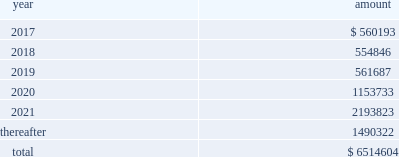New term loan a facility , with the remaining unpaid principal amount of loans under the new term loan a facility due and payable in full at maturity on june 6 , 2021 .
Principal amounts outstanding under the new revolving loan facility are due and payable in full at maturity on june 6 , 2021 , subject to earlier repayment pursuant to the springing maturity date described above .
In addition to paying interest on outstanding principal under the borrowings , we are obligated to pay a quarterly commitment fee at a rate determined by reference to a total leverage ratio , with a maximum commitment fee of 40% ( 40 % ) of the applicable margin for eurocurrency loans .
In july 2016 , breakaway four , ltd. , as borrower , and nclc , as guarantor , entered into a supplemental agreement , which amended the breakaway four loan to , among other things , increase the aggregate principal amount of commitments under the multi-draw term loan credit facility from 20ac590.5 million to 20ac729.9 million .
In june 2016 , we took delivery of seven seas explorer .
To finance the payment due upon delivery , we had export credit financing in place for 80% ( 80 % ) of the contract price .
The associated $ 373.6 million term loan bears interest at 3.43% ( 3.43 % ) with a maturity date of june 30 , 2028 .
Principal and interest payments shall be paid semiannually .
In december 2016 , nclc issued $ 700.0 million aggregate principal amount of 4.750% ( 4.750 % ) senior unsecured notes due december 2021 ( the 201cnotes 201d ) in a private offering ( the 201coffering 201d ) at par .
Nclc used the net proceeds from the offering , after deducting the initial purchasers 2019 discount and estimated fees and expenses , together with cash on hand , to purchase its outstanding 5.25% ( 5.25 % ) senior notes due 2019 having an aggregate outstanding principal amount of $ 680 million .
The redemption of the 5.25% ( 5.25 % ) senior notes due 2019 was completed in january 2017 .
Nclc will pay interest on the notes at 4.750% ( 4.750 % ) per annum , semiannually on june 15 and december 15 of each year , commencing on june 15 , 2017 , to holders of record at the close of business on the immediately preceding june 1 and december 1 , respectively .
Nclc may redeem the notes , in whole or part , at any time prior to december 15 , 2018 , at a price equal to 100% ( 100 % ) of the principal amount of the notes redeemed plus accrued and unpaid interest to , but not including , the redemption date and a 201cmake-whole premium . 201d nclc may redeem the notes , in whole or in part , on or after december 15 , 2018 , at the redemption prices set forth in the indenture governing the notes .
At any time ( which may be more than once ) on or prior to december 15 , 2018 , nclc may choose to redeem up to 40% ( 40 % ) of the aggregate principal amount of the notes at a redemption price equal to 104.750% ( 104.750 % ) of the face amount thereof with an amount equal to the net proceeds of one or more equity offerings , so long as at least 60% ( 60 % ) of the aggregate principal amount of the notes issued remains outstanding following such redemption .
The indenture governing the notes contains covenants that limit nclc 2019s ability ( and its restricted subsidiaries 2019 ability ) to , among other things : ( i ) incur or guarantee additional indebtedness or issue certain preferred shares ; ( ii ) pay dividends and make certain other restricted payments ; ( iii ) create restrictions on the payment of dividends or other distributions to nclc from its restricted subsidiaries ; ( iv ) create liens on certain assets to secure debt ; ( v ) make certain investments ; ( vi ) engage in transactions with affiliates ; ( vii ) engage in sales of assets and subsidiary stock ; and ( viii ) transfer all or substantially all of its assets or enter into merger or consolidation transactions .
The indenture governing the notes also provides for events of default , which , if any of them occurs , would permit or require the principal , premium ( if any ) , interest and other monetary obligations on all of the then-outstanding notes to become due and payable immediately .
Interest expense , net for the year ended december 31 , 2016 was $ 276.9 million which included $ 34.7 million of amortization of deferred financing fees and a $ 27.7 million loss on extinguishment of debt .
Interest expense , net for the year ended december 31 , 2015 was $ 221.9 million which included $ 36.7 million of amortization of deferred financing fees and a $ 12.7 million loss on extinguishment of debt .
Interest expense , net for the year ended december 31 , 2014 was $ 151.8 million which included $ 32.3 million of amortization of deferred financing fees and $ 15.4 million of expenses related to financing transactions in connection with the acquisition of prestige .
Certain of our debt agreements contain covenants that , among other things , require us to maintain a minimum level of liquidity , as well as limit our net funded debt-to-capital ratio , maintain certain other ratios and restrict our ability to pay dividends .
Substantially all of our ships and other property and equipment are pledged as collateral for certain of our debt .
We believe we were in compliance with these covenants as of december 31 , 2016 .
The following are scheduled principal repayments on long-term debt including capital lease obligations as of december 31 , 2016 for each of the next five years ( in thousands ) : .
We had an accrued interest liability of $ 32.5 million and $ 34.2 million as of december 31 , 2016 and 2015 , respectively. .
From 2014 to 2016 , what was the total amount of money they can deduct from their future income tax due to amortization? 
Rationale: to find the total amount of money they can deduct from future income tax due to amortization , one must added up the amount of amortization from the years of 201420152016
Computations: (32.3 + (34.7 + 36.7))
Answer: 103.7. 